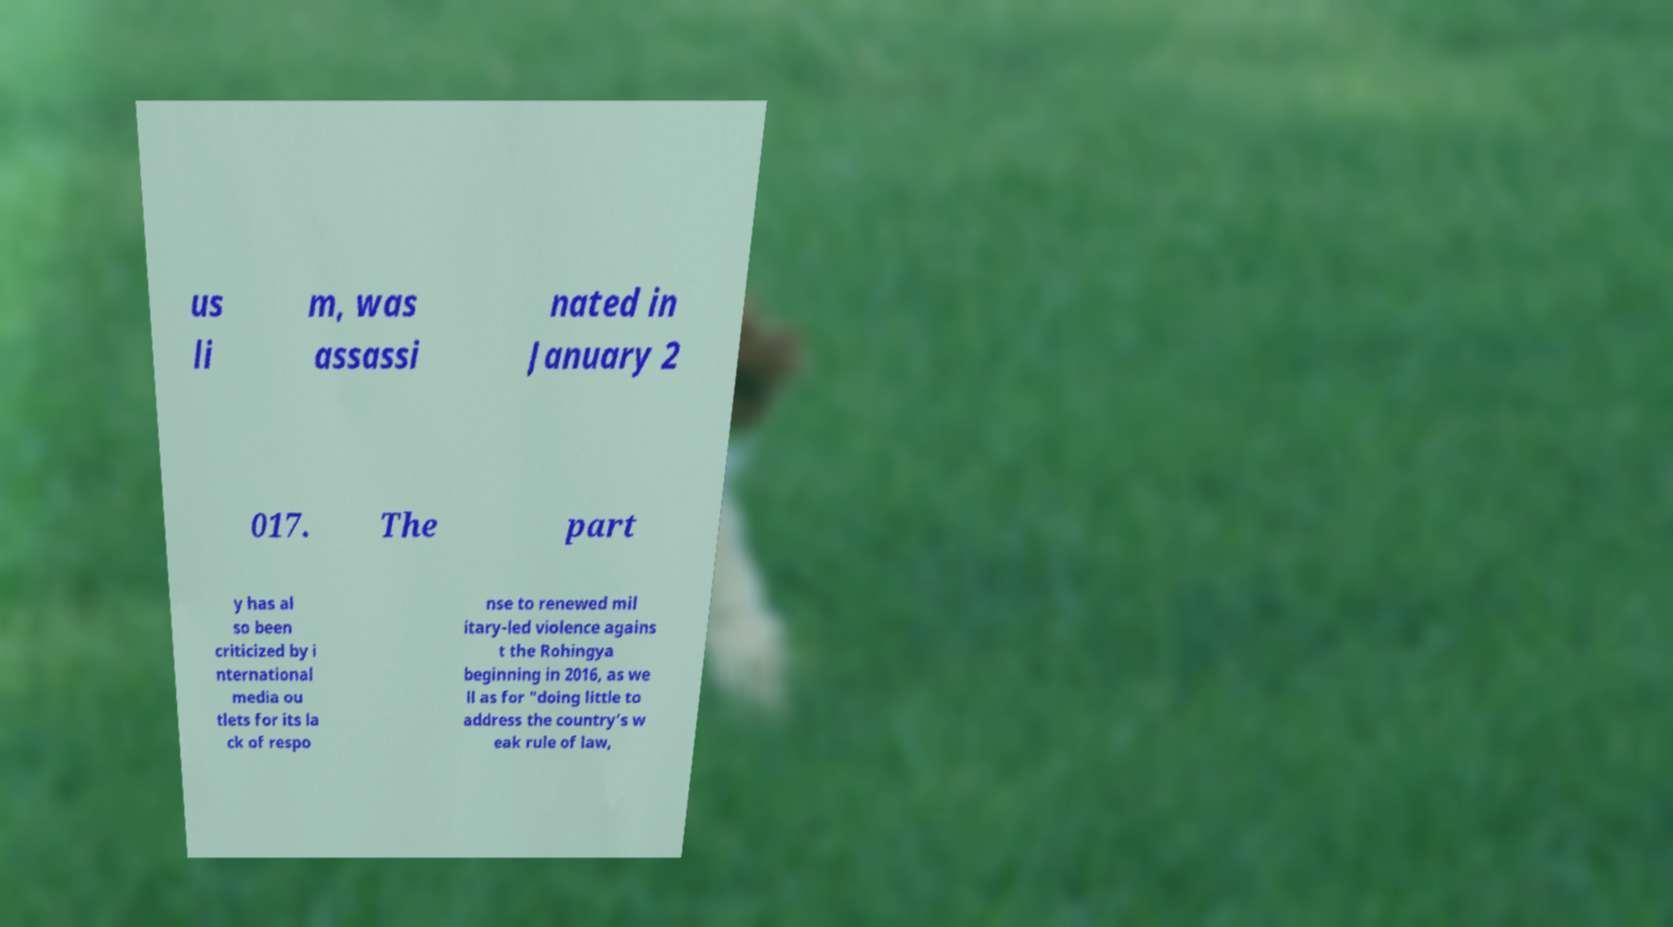What messages or text are displayed in this image? I need them in a readable, typed format. us li m, was assassi nated in January 2 017. The part y has al so been criticized by i nternational media ou tlets for its la ck of respo nse to renewed mil itary-led violence agains t the Rohingya beginning in 2016, as we ll as for "doing little to address the country’s w eak rule of law, 